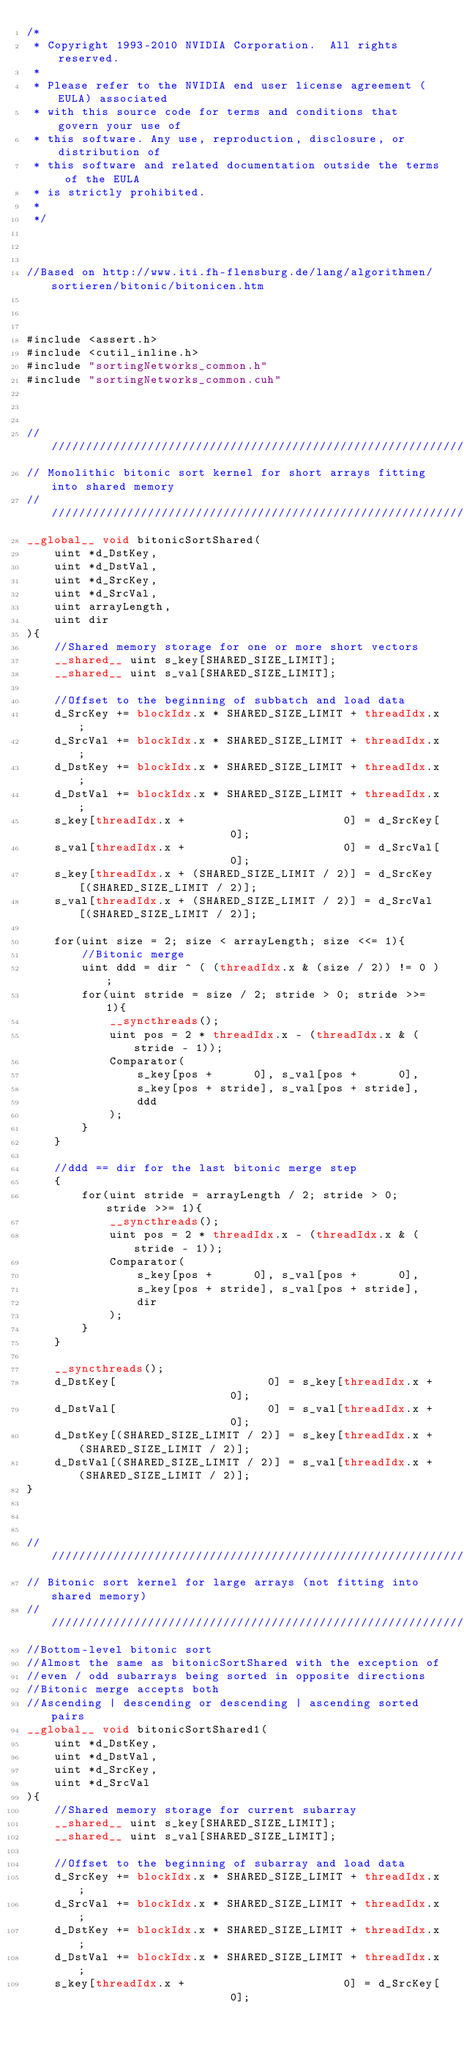Convert code to text. <code><loc_0><loc_0><loc_500><loc_500><_Cuda_>/*
 * Copyright 1993-2010 NVIDIA Corporation.  All rights reserved.
 *
 * Please refer to the NVIDIA end user license agreement (EULA) associated
 * with this source code for terms and conditions that govern your use of
 * this software. Any use, reproduction, disclosure, or distribution of
 * this software and related documentation outside the terms of the EULA
 * is strictly prohibited.
 *
 */



//Based on http://www.iti.fh-flensburg.de/lang/algorithmen/sortieren/bitonic/bitonicen.htm



#include <assert.h>
#include <cutil_inline.h>
#include "sortingNetworks_common.h"
#include "sortingNetworks_common.cuh"



////////////////////////////////////////////////////////////////////////////////
// Monolithic bitonic sort kernel for short arrays fitting into shared memory
////////////////////////////////////////////////////////////////////////////////
__global__ void bitonicSortShared(
    uint *d_DstKey,
    uint *d_DstVal,
    uint *d_SrcKey,
    uint *d_SrcVal,
    uint arrayLength,
    uint dir
){
    //Shared memory storage for one or more short vectors
    __shared__ uint s_key[SHARED_SIZE_LIMIT];
    __shared__ uint s_val[SHARED_SIZE_LIMIT];

    //Offset to the beginning of subbatch and load data
    d_SrcKey += blockIdx.x * SHARED_SIZE_LIMIT + threadIdx.x;
    d_SrcVal += blockIdx.x * SHARED_SIZE_LIMIT + threadIdx.x;
    d_DstKey += blockIdx.x * SHARED_SIZE_LIMIT + threadIdx.x;
    d_DstVal += blockIdx.x * SHARED_SIZE_LIMIT + threadIdx.x;
    s_key[threadIdx.x +                       0] = d_SrcKey[                      0];
    s_val[threadIdx.x +                       0] = d_SrcVal[                      0];
    s_key[threadIdx.x + (SHARED_SIZE_LIMIT / 2)] = d_SrcKey[(SHARED_SIZE_LIMIT / 2)];
    s_val[threadIdx.x + (SHARED_SIZE_LIMIT / 2)] = d_SrcVal[(SHARED_SIZE_LIMIT / 2)];

    for(uint size = 2; size < arrayLength; size <<= 1){
        //Bitonic merge
        uint ddd = dir ^ ( (threadIdx.x & (size / 2)) != 0 );
        for(uint stride = size / 2; stride > 0; stride >>= 1){
            __syncthreads();
            uint pos = 2 * threadIdx.x - (threadIdx.x & (stride - 1));
            Comparator(
                s_key[pos +      0], s_val[pos +      0],
                s_key[pos + stride], s_val[pos + stride],
                ddd
            );
        }
    }

    //ddd == dir for the last bitonic merge step
    {
        for(uint stride = arrayLength / 2; stride > 0; stride >>= 1){
            __syncthreads();
            uint pos = 2 * threadIdx.x - (threadIdx.x & (stride - 1));
            Comparator(
                s_key[pos +      0], s_val[pos +      0],
                s_key[pos + stride], s_val[pos + stride],
                dir
            );
        }
    }

    __syncthreads();
    d_DstKey[                      0] = s_key[threadIdx.x +                       0];
    d_DstVal[                      0] = s_val[threadIdx.x +                       0];
    d_DstKey[(SHARED_SIZE_LIMIT / 2)] = s_key[threadIdx.x + (SHARED_SIZE_LIMIT / 2)];
    d_DstVal[(SHARED_SIZE_LIMIT / 2)] = s_val[threadIdx.x + (SHARED_SIZE_LIMIT / 2)];
}



////////////////////////////////////////////////////////////////////////////////
// Bitonic sort kernel for large arrays (not fitting into shared memory)
////////////////////////////////////////////////////////////////////////////////
//Bottom-level bitonic sort
//Almost the same as bitonicSortShared with the exception of
//even / odd subarrays being sorted in opposite directions
//Bitonic merge accepts both
//Ascending | descending or descending | ascending sorted pairs
__global__ void bitonicSortShared1(
    uint *d_DstKey,
    uint *d_DstVal,
    uint *d_SrcKey,
    uint *d_SrcVal
){
    //Shared memory storage for current subarray
    __shared__ uint s_key[SHARED_SIZE_LIMIT];
    __shared__ uint s_val[SHARED_SIZE_LIMIT];

    //Offset to the beginning of subarray and load data
    d_SrcKey += blockIdx.x * SHARED_SIZE_LIMIT + threadIdx.x;
    d_SrcVal += blockIdx.x * SHARED_SIZE_LIMIT + threadIdx.x;
    d_DstKey += blockIdx.x * SHARED_SIZE_LIMIT + threadIdx.x;
    d_DstVal += blockIdx.x * SHARED_SIZE_LIMIT + threadIdx.x;
    s_key[threadIdx.x +                       0] = d_SrcKey[                      0];</code> 